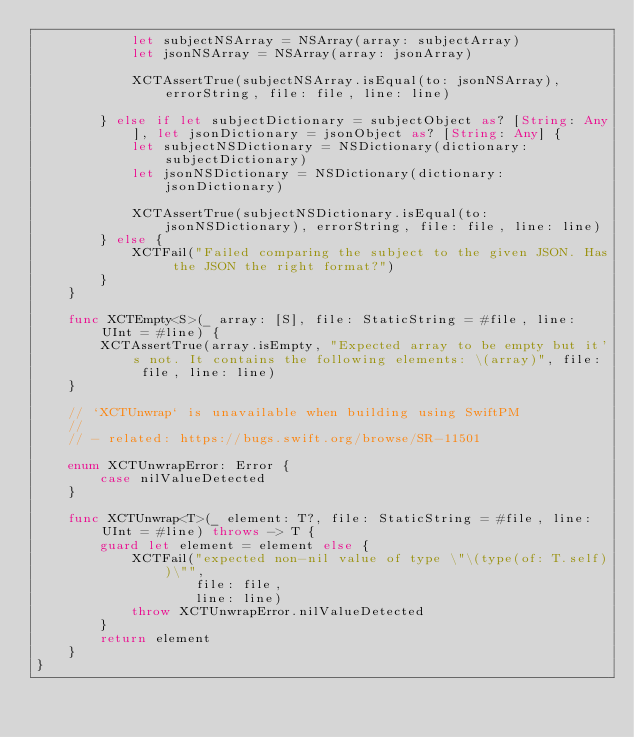<code> <loc_0><loc_0><loc_500><loc_500><_Swift_>            let subjectNSArray = NSArray(array: subjectArray)
            let jsonNSArray = NSArray(array: jsonArray)

            XCTAssertTrue(subjectNSArray.isEqual(to: jsonNSArray), errorString, file: file, line: line)

        } else if let subjectDictionary = subjectObject as? [String: Any], let jsonDictionary = jsonObject as? [String: Any] {
            let subjectNSDictionary = NSDictionary(dictionary: subjectDictionary)
            let jsonNSDictionary = NSDictionary(dictionary: jsonDictionary)

            XCTAssertTrue(subjectNSDictionary.isEqual(to: jsonNSDictionary), errorString, file: file, line: line)
        } else {
            XCTFail("Failed comparing the subject to the given JSON. Has the JSON the right format?")
        }
    }

    func XCTEmpty<S>(_ array: [S], file: StaticString = #file, line: UInt = #line) {
        XCTAssertTrue(array.isEmpty, "Expected array to be empty but it's not. It contains the following elements: \(array)", file: file, line: line)
    }

    // `XCTUnwrap` is unavailable when building using SwiftPM
    //
    // - related: https://bugs.swift.org/browse/SR-11501

    enum XCTUnwrapError: Error {
        case nilValueDetected
    }

    func XCTUnwrap<T>(_ element: T?, file: StaticString = #file, line: UInt = #line) throws -> T {
        guard let element = element else {
            XCTFail("expected non-nil value of type \"\(type(of: T.self))\"",
                    file: file,
                    line: line)
            throw XCTUnwrapError.nilValueDetected
        }
        return element
    }
}
</code> 